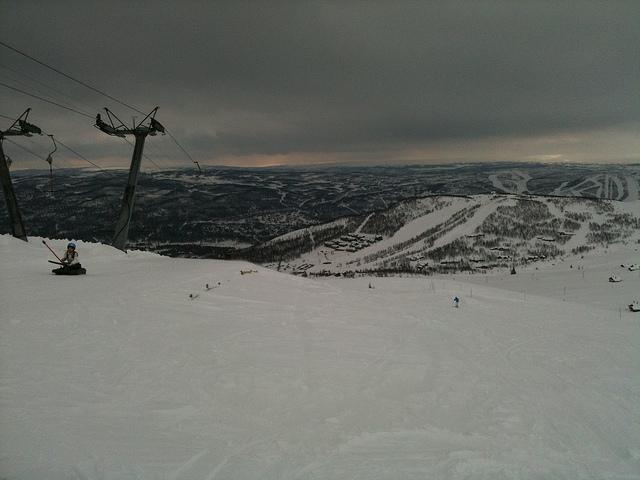What are the overhead cables for?
Indicate the correct choice and explain in the format: 'Answer: answer
Rationale: rationale.'
Options: Guiding skiers, carry electricity, decorative only, carry skiers. Answer: carry skiers.
Rationale: Ski slopes have ski lifts that take people from the bottom of the slope to the top 